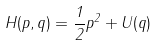<formula> <loc_0><loc_0><loc_500><loc_500>H ( p , q ) = \frac { 1 } { 2 } p ^ { 2 } + U ( q )</formula> 